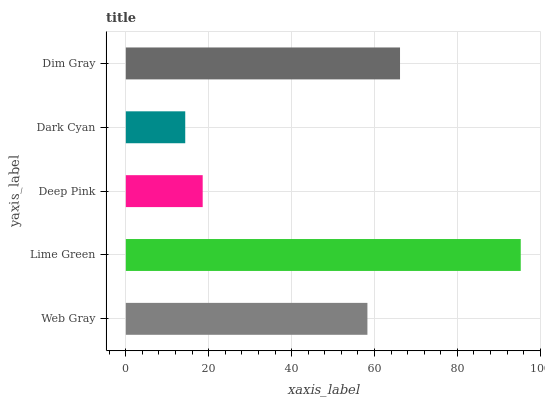Is Dark Cyan the minimum?
Answer yes or no. Yes. Is Lime Green the maximum?
Answer yes or no. Yes. Is Deep Pink the minimum?
Answer yes or no. No. Is Deep Pink the maximum?
Answer yes or no. No. Is Lime Green greater than Deep Pink?
Answer yes or no. Yes. Is Deep Pink less than Lime Green?
Answer yes or no. Yes. Is Deep Pink greater than Lime Green?
Answer yes or no. No. Is Lime Green less than Deep Pink?
Answer yes or no. No. Is Web Gray the high median?
Answer yes or no. Yes. Is Web Gray the low median?
Answer yes or no. Yes. Is Lime Green the high median?
Answer yes or no. No. Is Lime Green the low median?
Answer yes or no. No. 